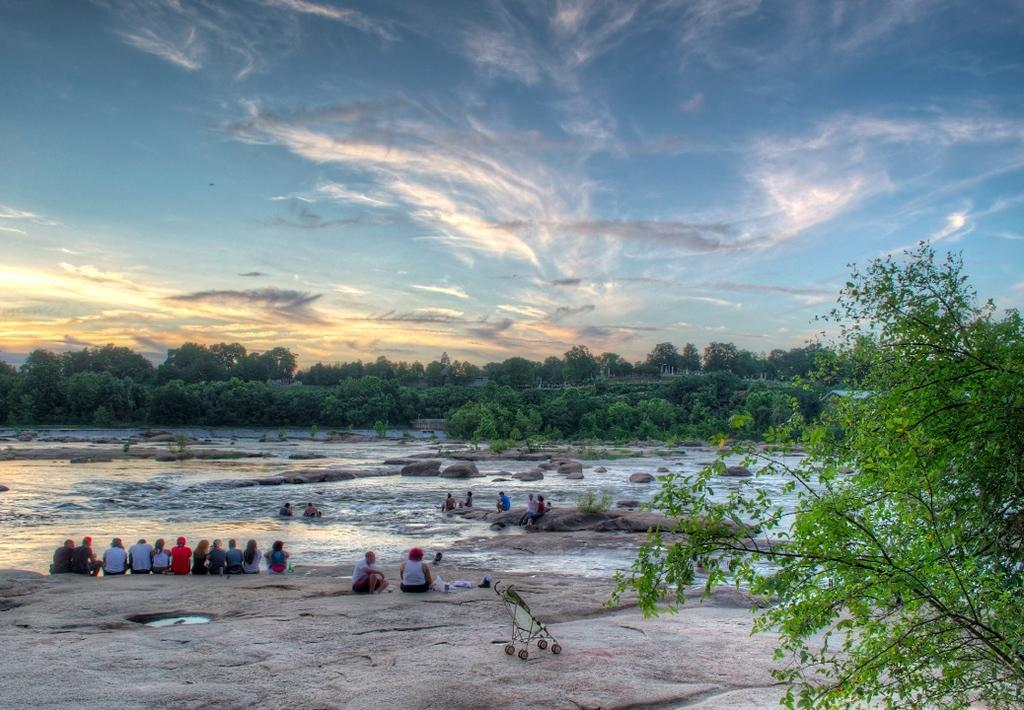What type of vegetation can be seen in the image? There are trees in the image. What can be seen in the sky in the image? There are clouds in the image. What is visible in the background of the image? The sky is visible in the image. What is the water feature in the image? There is water visible in the image. What are the people in the image doing? The people are sitting in the image. Where is the hen located in the image? There is no hen present in the image. What type of blade can be seen cutting through the trees in the image? There is no blade cutting through the trees in the image. 